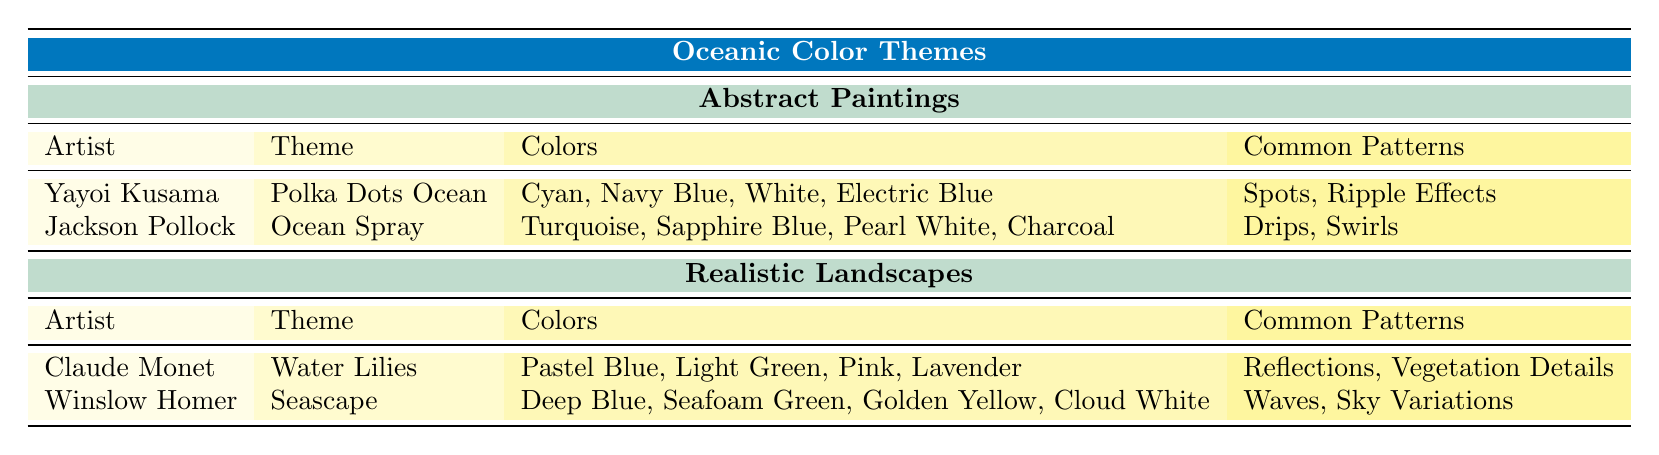What are the colors used in Yayoi Kusama's theme? According to the table, Yayoi Kusama's theme "Polka Dots Ocean" uses the colors Cyan, Navy Blue, White, and Electric Blue.
Answer: Cyan, Navy Blue, White, Electric Blue Which artist created the theme "Seascape"? The table indicates that Winslow Homer created the theme "Seascape".
Answer: Winslow Homer Are there any common patterns listed for Jackson Pollock's work? Yes, the table shows that Jackson Pollock's common patterns for the theme "Ocean Spray" are Drips and Swirls.
Answer: Yes What is the difference in the number of color themes between Abstract Paintings and Realistic Landscapes? Abstract paintings feature 2 themes (Polka Dots Ocean and Ocean Spray), while realistic landscapes feature 2 themes as well (Water Lilies and Seascape). The difference is 0, indicating they have an equal number of themes.
Answer: 0 Do both artists in Realistic Landscapes utilize shades of blue in their themes? Yes, both Claude Monet's "Water Lilies" and Winslow Homer's "Seascape" include shades of blue; Monet uses Pastel Blue and Homer uses Deep Blue.
Answer: Yes Which artist uses a theme that includes "Ripple Effects" as a common pattern? The table identifies Yayoi Kusama as the artist who includes "Ripple Effects" in her theme "Polka Dots Ocean".
Answer: Yayoi Kusama What is the common pattern for Claude Monet's theme "Water Lilies"? The table states that the common patterns for Claude Monet's theme "Water Lilies" are Reflections and Vegetation Details.
Answer: Reflections, Vegetation Details Which abstract painting artist uses colors that include "Sapphire Blue"? The table shows that Jackson Pollock, in his theme "Ocean Spray", uses the color Sapphire Blue.
Answer: Jackson Pollock How many total colors are used in Winslow Homer's theme "Seascape"? Winslow Homer uses 4 colors in the theme "Seascape" as listed in the table: Deep Blue, Seafoam Green, Golden Yellow, and Cloud White.
Answer: 4 